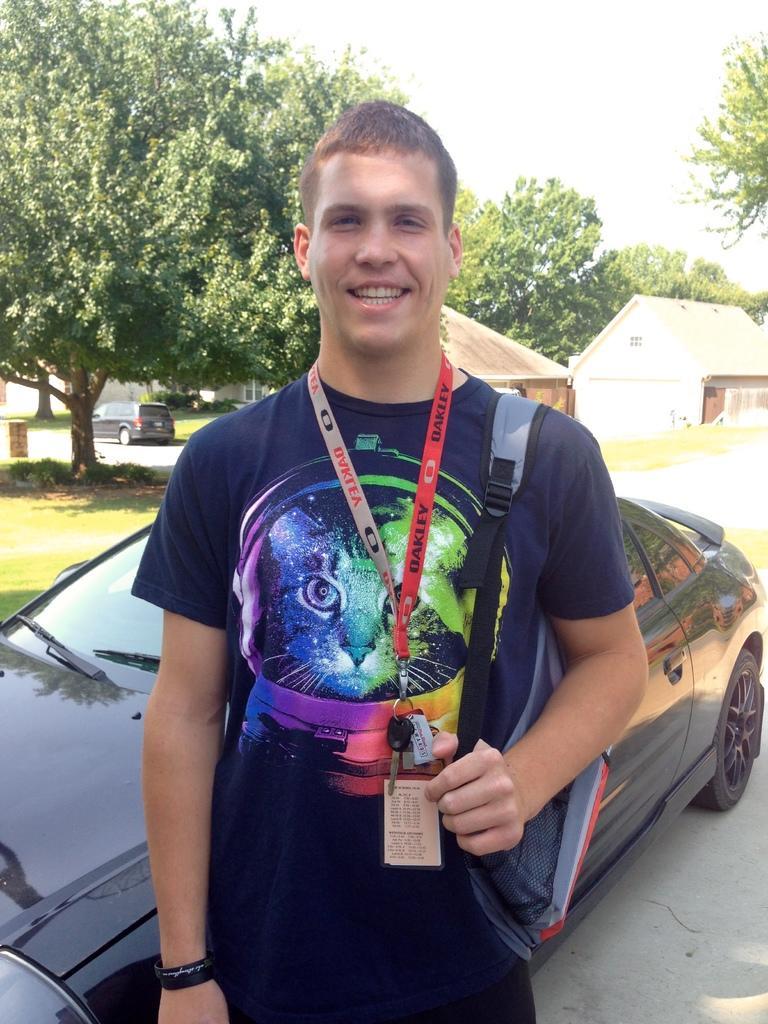Could you give a brief overview of what you see in this image? In the picture I can see a person wearing blue color T-shirt also wearing ID card, carrying bag standing, there is black color car and in the background there are some trees, houses and clear sky. 